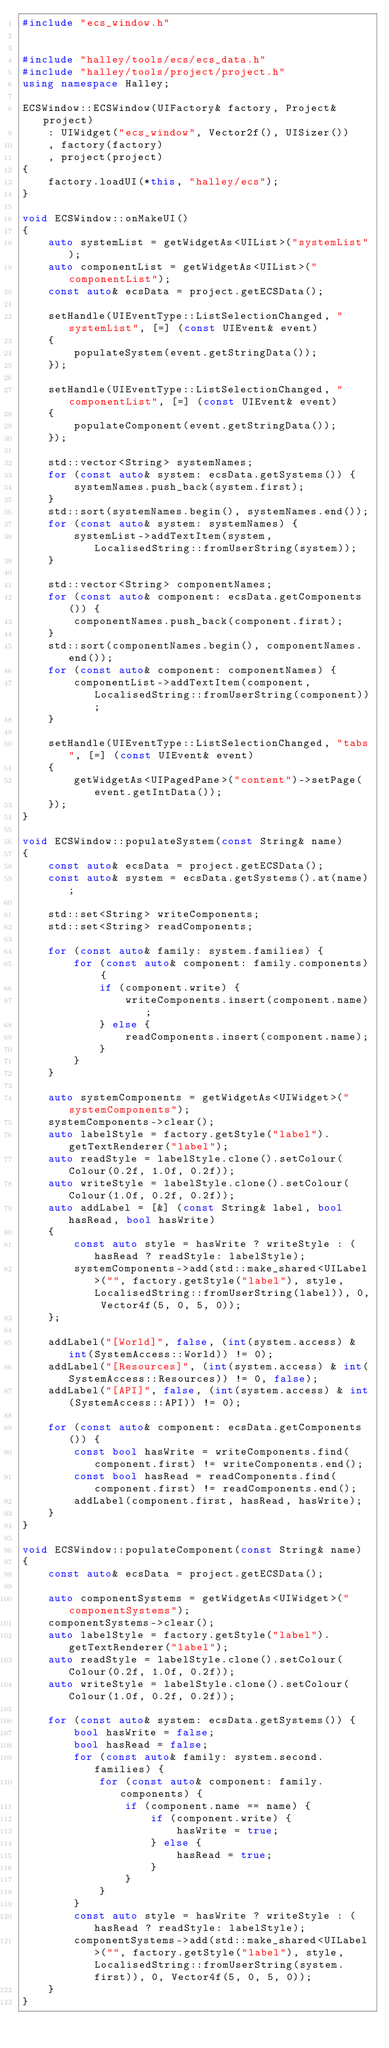Convert code to text. <code><loc_0><loc_0><loc_500><loc_500><_C++_>#include "ecs_window.h"


#include "halley/tools/ecs/ecs_data.h"
#include "halley/tools/project/project.h"
using namespace Halley;

ECSWindow::ECSWindow(UIFactory& factory, Project& project)
	: UIWidget("ecs_window", Vector2f(), UISizer())
	, factory(factory)
	, project(project)
{
	factory.loadUI(*this, "halley/ecs");
}

void ECSWindow::onMakeUI()
{
	auto systemList = getWidgetAs<UIList>("systemList");
	auto componentList = getWidgetAs<UIList>("componentList");
	const auto& ecsData = project.getECSData();

	setHandle(UIEventType::ListSelectionChanged, "systemList", [=] (const UIEvent& event)
	{
		populateSystem(event.getStringData());
	});
	
	setHandle(UIEventType::ListSelectionChanged, "componentList", [=] (const UIEvent& event)
	{
		populateComponent(event.getStringData());
	});

	std::vector<String> systemNames;
	for (const auto& system: ecsData.getSystems()) {
		systemNames.push_back(system.first);
	}
	std::sort(systemNames.begin(), systemNames.end());
	for (const auto& system: systemNames) {
		systemList->addTextItem(system, LocalisedString::fromUserString(system));
	}

	std::vector<String> componentNames;
	for (const auto& component: ecsData.getComponents()) {
		componentNames.push_back(component.first);
	}
	std::sort(componentNames.begin(), componentNames.end());
	for (const auto& component: componentNames) {
		componentList->addTextItem(component, LocalisedString::fromUserString(component));
	}

	setHandle(UIEventType::ListSelectionChanged, "tabs", [=] (const UIEvent& event)
	{
		getWidgetAs<UIPagedPane>("content")->setPage(event.getIntData());
	});
}

void ECSWindow::populateSystem(const String& name)
{
	const auto& ecsData = project.getECSData();
	const auto& system = ecsData.getSystems().at(name);

	std::set<String> writeComponents;
	std::set<String> readComponents;

	for (const auto& family: system.families) {
		for (const auto& component: family.components) {
			if (component.write) {
				writeComponents.insert(component.name);
			} else {
				readComponents.insert(component.name);
			}
		}
	}

	auto systemComponents = getWidgetAs<UIWidget>("systemComponents");
	systemComponents->clear();
	auto labelStyle = factory.getStyle("label").getTextRenderer("label");
	auto readStyle = labelStyle.clone().setColour(Colour(0.2f, 1.0f, 0.2f));
	auto writeStyle = labelStyle.clone().setColour(Colour(1.0f, 0.2f, 0.2f));
	auto addLabel = [&] (const String& label, bool hasRead, bool hasWrite)
	{
		const auto style = hasWrite ? writeStyle : (hasRead ? readStyle: labelStyle);
		systemComponents->add(std::make_shared<UILabel>("", factory.getStyle("label"), style, LocalisedString::fromUserString(label)), 0, Vector4f(5, 0, 5, 0));
	};

	addLabel("[World]", false, (int(system.access) & int(SystemAccess::World)) != 0);
	addLabel("[Resources]", (int(system.access) & int(SystemAccess::Resources)) != 0, false);
	addLabel("[API]", false, (int(system.access) & int(SystemAccess::API)) != 0);
	
	for (const auto& component: ecsData.getComponents()) {
		const bool hasWrite = writeComponents.find(component.first) != writeComponents.end();
		const bool hasRead = readComponents.find(component.first) != readComponents.end();
		addLabel(component.first, hasRead, hasWrite);
	}
}

void ECSWindow::populateComponent(const String& name)
{
	const auto& ecsData = project.getECSData();
	
	auto componentSystems = getWidgetAs<UIWidget>("componentSystems");
	componentSystems->clear();
	auto labelStyle = factory.getStyle("label").getTextRenderer("label");
	auto readStyle = labelStyle.clone().setColour(Colour(0.2f, 1.0f, 0.2f));
	auto writeStyle = labelStyle.clone().setColour(Colour(1.0f, 0.2f, 0.2f));
	
	for (const auto& system: ecsData.getSystems()) {
		bool hasWrite = false;
		bool hasRead = false;
		for (const auto& family: system.second.families) {
			for (const auto& component: family.components) {
				if (component.name == name) {
					if (component.write) {
						hasWrite = true;
					} else {
						hasRead = true;
					}
				}
			}
		}
		const auto style = hasWrite ? writeStyle : (hasRead ? readStyle: labelStyle);
		componentSystems->add(std::make_shared<UILabel>("", factory.getStyle("label"), style, LocalisedString::fromUserString(system.first)), 0, Vector4f(5, 0, 5, 0));
	}
}
</code> 